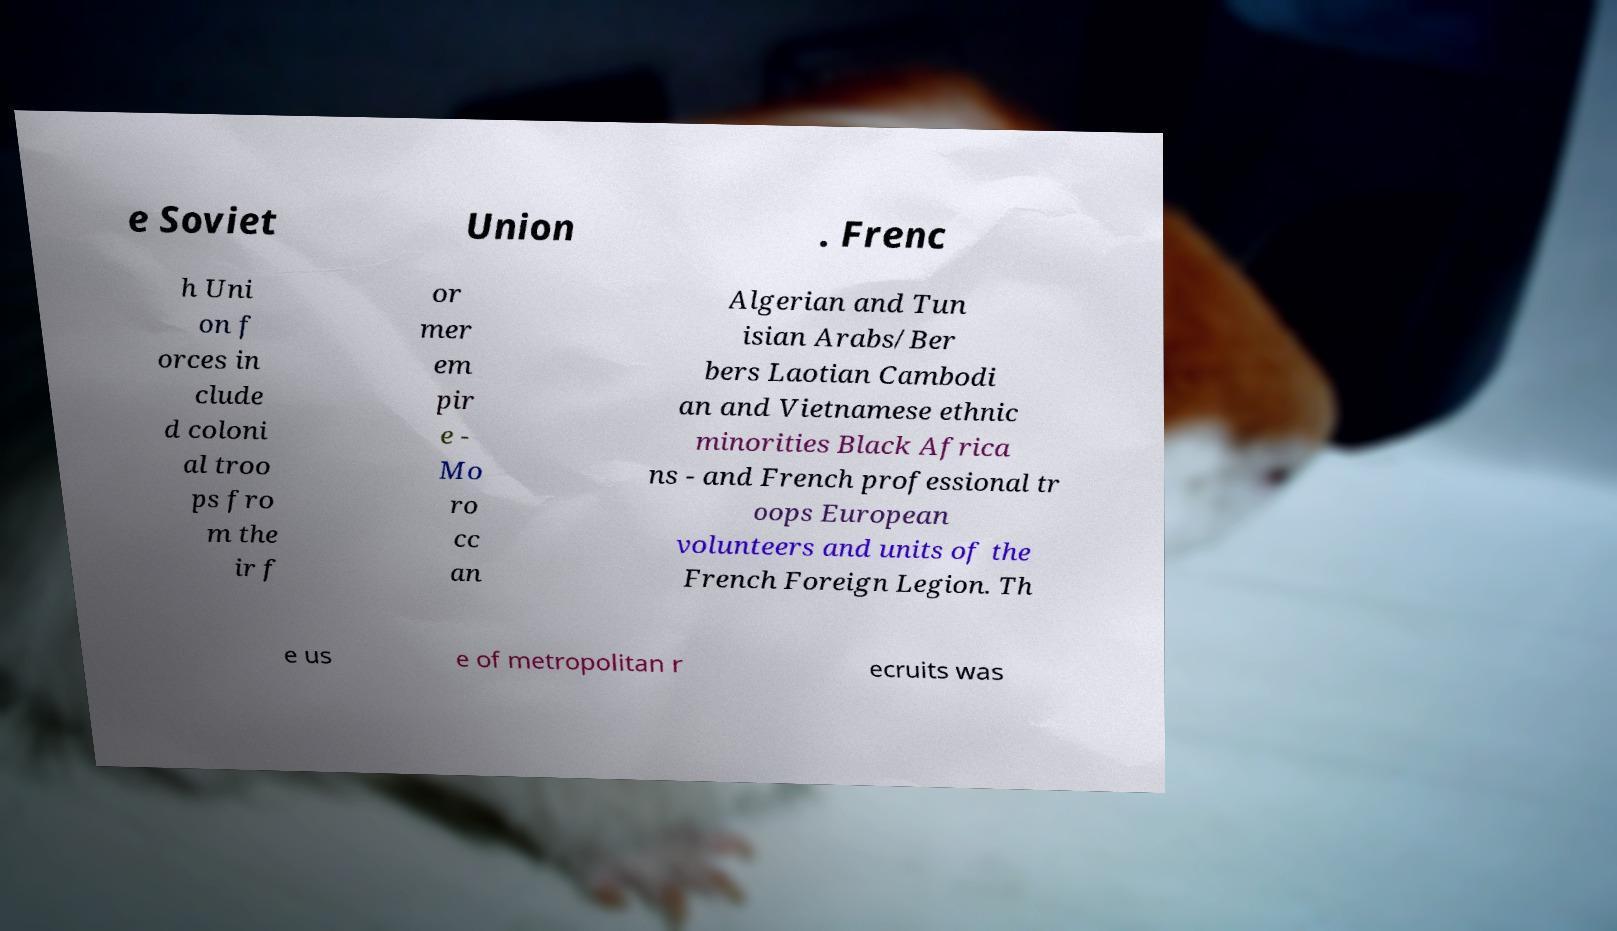What messages or text are displayed in this image? I need them in a readable, typed format. e Soviet Union . Frenc h Uni on f orces in clude d coloni al troo ps fro m the ir f or mer em pir e - Mo ro cc an Algerian and Tun isian Arabs/Ber bers Laotian Cambodi an and Vietnamese ethnic minorities Black Africa ns - and French professional tr oops European volunteers and units of the French Foreign Legion. Th e us e of metropolitan r ecruits was 